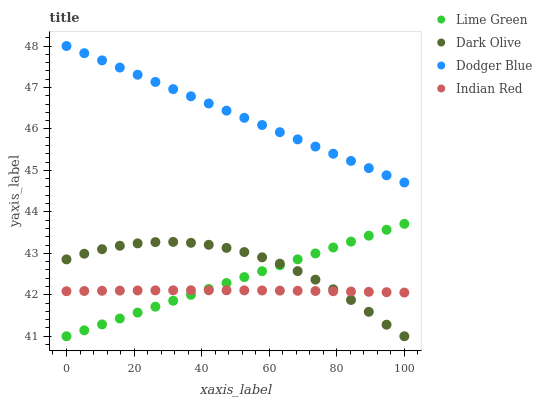Does Indian Red have the minimum area under the curve?
Answer yes or no. Yes. Does Dodger Blue have the maximum area under the curve?
Answer yes or no. Yes. Does Dark Olive have the minimum area under the curve?
Answer yes or no. No. Does Dark Olive have the maximum area under the curve?
Answer yes or no. No. Is Dodger Blue the smoothest?
Answer yes or no. Yes. Is Dark Olive the roughest?
Answer yes or no. Yes. Is Lime Green the smoothest?
Answer yes or no. No. Is Lime Green the roughest?
Answer yes or no. No. Does Dark Olive have the lowest value?
Answer yes or no. Yes. Does Indian Red have the lowest value?
Answer yes or no. No. Does Dodger Blue have the highest value?
Answer yes or no. Yes. Does Dark Olive have the highest value?
Answer yes or no. No. Is Lime Green less than Dodger Blue?
Answer yes or no. Yes. Is Dodger Blue greater than Indian Red?
Answer yes or no. Yes. Does Indian Red intersect Dark Olive?
Answer yes or no. Yes. Is Indian Red less than Dark Olive?
Answer yes or no. No. Is Indian Red greater than Dark Olive?
Answer yes or no. No. Does Lime Green intersect Dodger Blue?
Answer yes or no. No. 